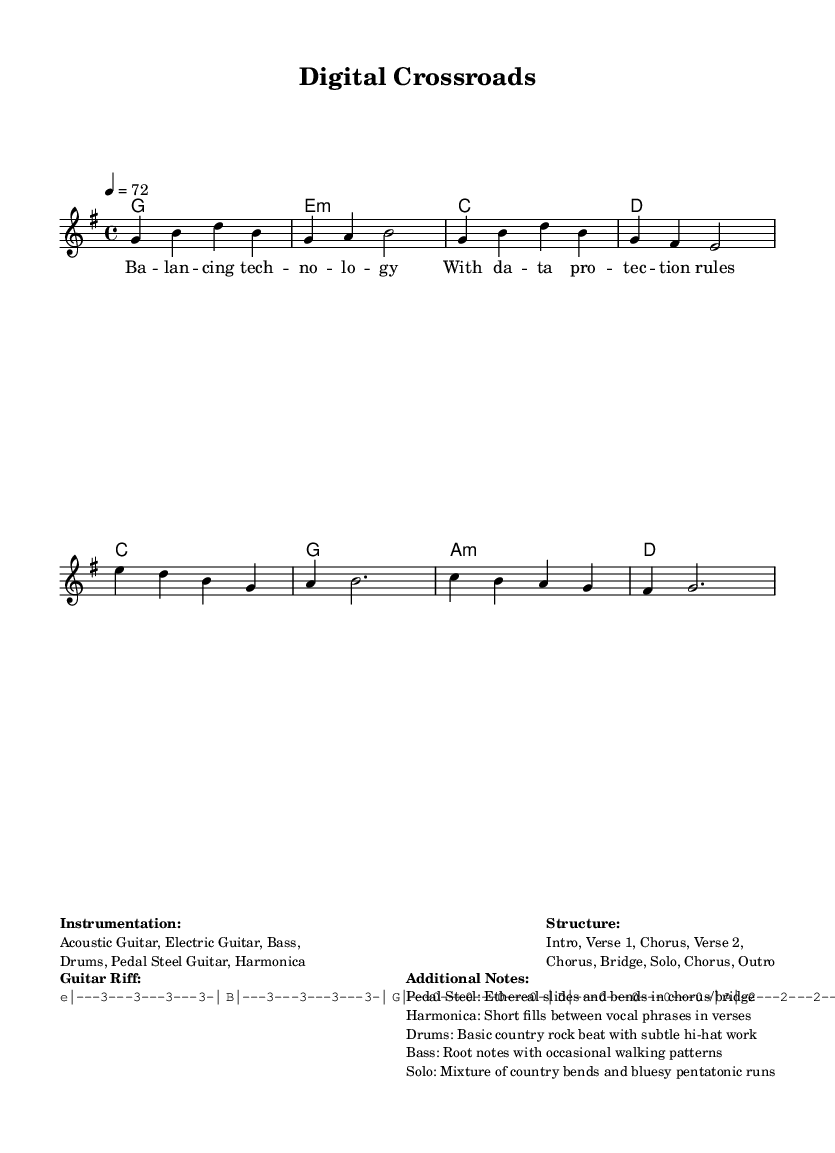What is the key signature of this music? The key signature is indicated by the sharps or flats present at the beginning of the staff. Here, it shows one sharp (F#), which defines the G major key.
Answer: G major What is the time signature of this music? The time signature appears at the beginning and indicates how many beats are in each measure. In this case, it reads 4/4, meaning there are four beats per measure, with the quarter note getting one beat.
Answer: 4/4 What is the tempo of this music? The tempo is specified in beats per minute, indicated in the score as "4 = 72," which means the quarter note should be played at a speed of 72 beats per minute.
Answer: 72 What is the first chord played in the verse? The chord symbols listed correspond to the harmonies played during the sections of the song. The first harmony listed for the verse is G major.
Answer: G How many instruments are indicated in the instrumentation? The instrumentation section lists several instruments used in the arrangement. Counting the items listed (Acoustic Guitar, Electric Guitar, Bass, Drums, Pedal Steel Guitar, Harmonica), we find there are six distinct instruments.
Answer: Six In which section does the solo occur? The structure of the song is outlined, providing the order of sections. The solo follows the bridge and precedes the final chorus, as indicated in the structural layout presented.
Answer: Solo What genre best describes this piece of music? The title and the lyrical themes suggest a combination of country music elements with rock influences, fulfilling the definition of country rock, which is a blend of these two musical styles.
Answer: Country Rock 